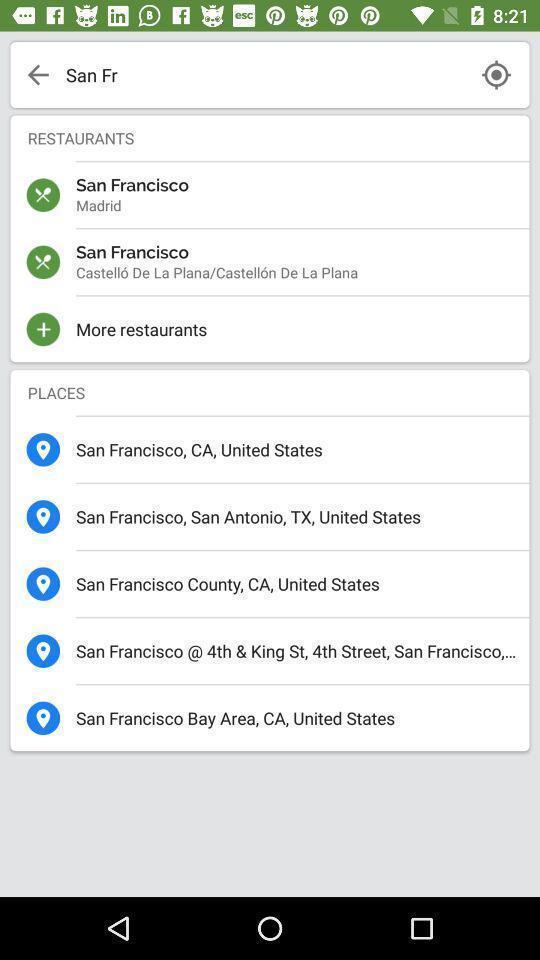Please provide a description for this image. Search page of a food booking app. 